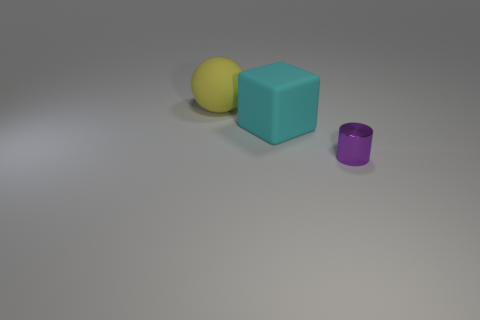Is the size of the cyan thing the same as the shiny cylinder?
Ensure brevity in your answer.  No. What is the purple cylinder made of?
Make the answer very short. Metal. There is a yellow sphere that is the same size as the rubber cube; what is it made of?
Your answer should be compact. Rubber. Are there any red rubber things that have the same size as the yellow thing?
Make the answer very short. No. Is the number of cyan rubber cubes on the left side of the yellow matte sphere the same as the number of purple metallic cylinders that are in front of the small purple metal object?
Your answer should be very brief. Yes. Is the number of things greater than the number of purple cylinders?
Your answer should be very brief. Yes. How many matte things are either purple cylinders or large objects?
Offer a terse response. 2. What number of metallic objects have the same color as the cube?
Make the answer very short. 0. What material is the large object that is on the left side of the big thing that is right of the large thing behind the big cyan rubber object made of?
Your response must be concise. Rubber. There is a thing that is to the left of the big rubber object that is in front of the big yellow ball; what color is it?
Offer a terse response. Yellow. 